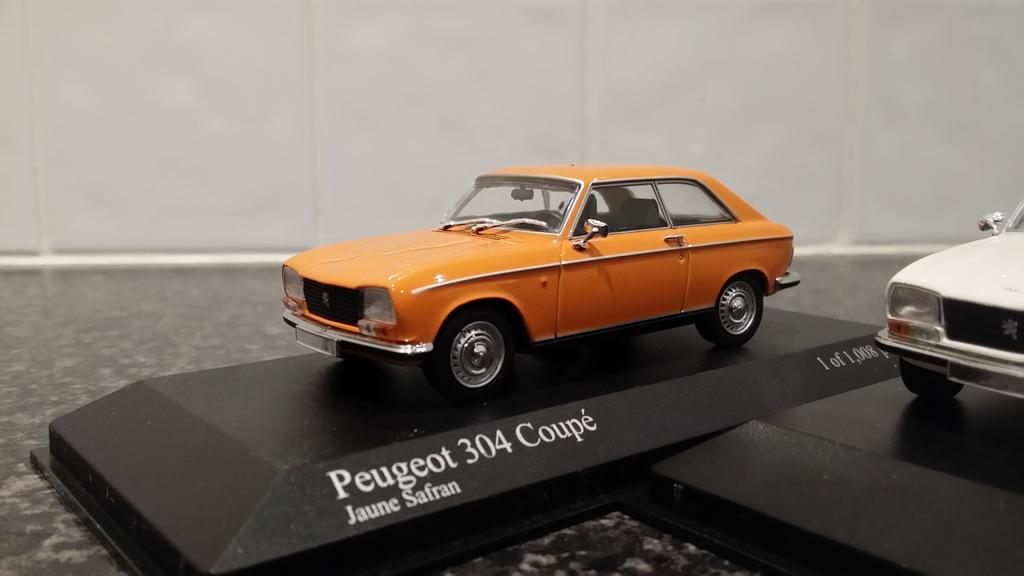What objects are present in the image? There are two toy cars in the image. How are the toy cars positioned? The toy cars are on boards. Can you describe the background of the image? The background of the image is blurred. What type of pets can be seen playing with the toy cars in the image? There are no pets present in the image, and the toy cars are not being played with. 